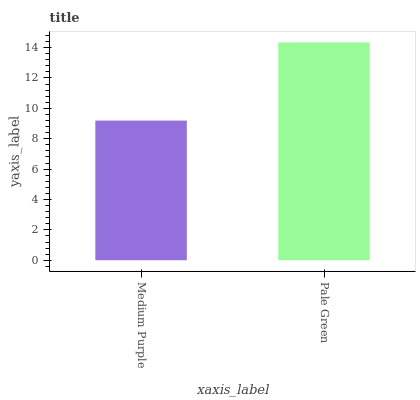Is Pale Green the minimum?
Answer yes or no. No. Is Pale Green greater than Medium Purple?
Answer yes or no. Yes. Is Medium Purple less than Pale Green?
Answer yes or no. Yes. Is Medium Purple greater than Pale Green?
Answer yes or no. No. Is Pale Green less than Medium Purple?
Answer yes or no. No. Is Pale Green the high median?
Answer yes or no. Yes. Is Medium Purple the low median?
Answer yes or no. Yes. Is Medium Purple the high median?
Answer yes or no. No. Is Pale Green the low median?
Answer yes or no. No. 